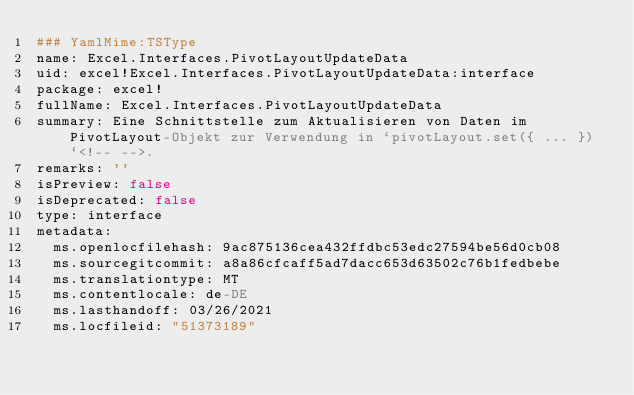<code> <loc_0><loc_0><loc_500><loc_500><_YAML_>### YamlMime:TSType
name: Excel.Interfaces.PivotLayoutUpdateData
uid: excel!Excel.Interfaces.PivotLayoutUpdateData:interface
package: excel!
fullName: Excel.Interfaces.PivotLayoutUpdateData
summary: Eine Schnittstelle zum Aktualisieren von Daten im PivotLayout-Objekt zur Verwendung in `pivotLayout.set({ ... })`<!-- -->.
remarks: ''
isPreview: false
isDeprecated: false
type: interface
metadata:
  ms.openlocfilehash: 9ac875136cea432ffdbc53edc27594be56d0cb08
  ms.sourcegitcommit: a8a86cfcaff5ad7dacc653d63502c76b1fedbebe
  ms.translationtype: MT
  ms.contentlocale: de-DE
  ms.lasthandoff: 03/26/2021
  ms.locfileid: "51373189"
</code> 